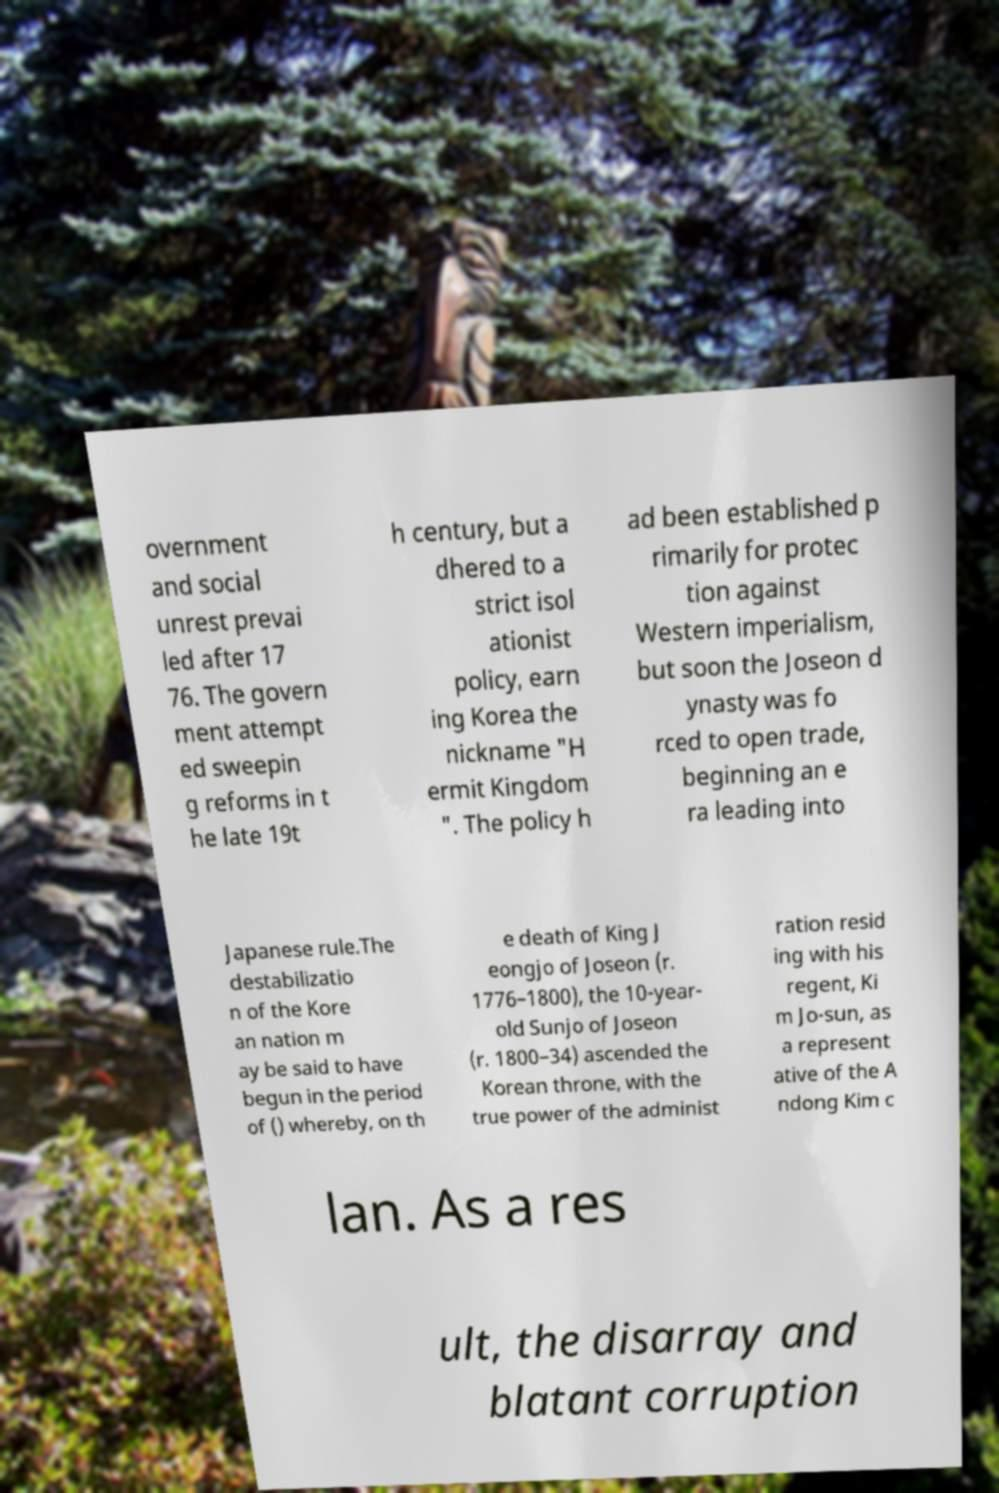For documentation purposes, I need the text within this image transcribed. Could you provide that? overnment and social unrest prevai led after 17 76. The govern ment attempt ed sweepin g reforms in t he late 19t h century, but a dhered to a strict isol ationist policy, earn ing Korea the nickname "H ermit Kingdom ". The policy h ad been established p rimarily for protec tion against Western imperialism, but soon the Joseon d ynasty was fo rced to open trade, beginning an e ra leading into Japanese rule.The destabilizatio n of the Kore an nation m ay be said to have begun in the period of () whereby, on th e death of King J eongjo of Joseon (r. 1776–1800), the 10-year- old Sunjo of Joseon (r. 1800–34) ascended the Korean throne, with the true power of the administ ration resid ing with his regent, Ki m Jo-sun, as a represent ative of the A ndong Kim c lan. As a res ult, the disarray and blatant corruption 